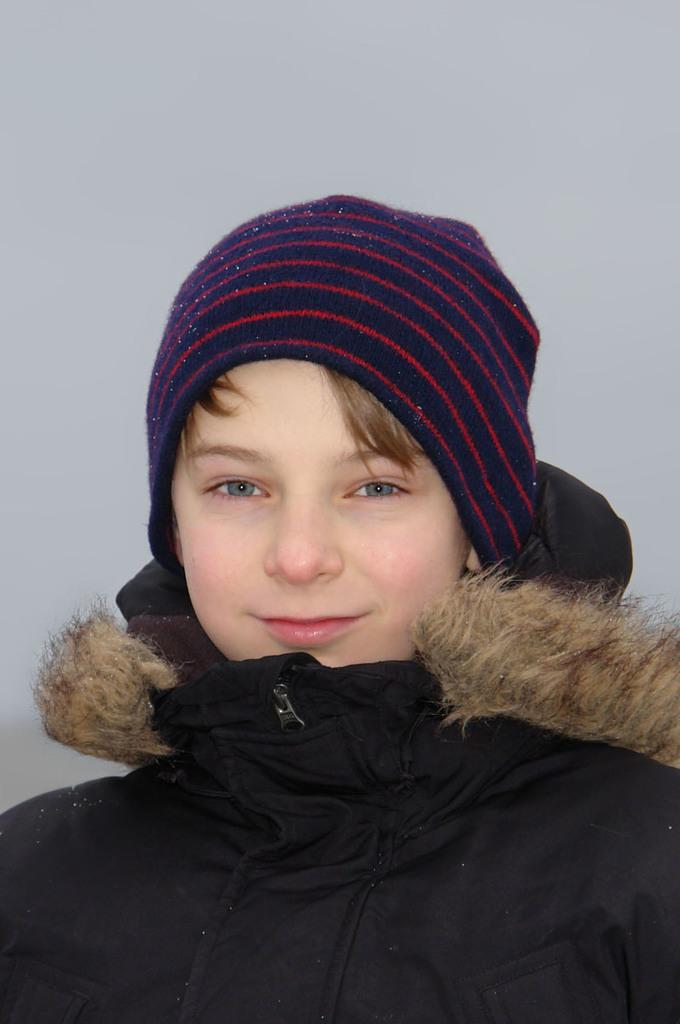Who or what is the main subject in the image? There is a person in the image. What can be observed about the background of the image? The background of the image is white. How many giants are present in the image? There are no giants present in the image; it features a person. What type of hand gesture is the person making in the image? The provided facts do not mention any hand gestures, so it cannot be determined from the image. 